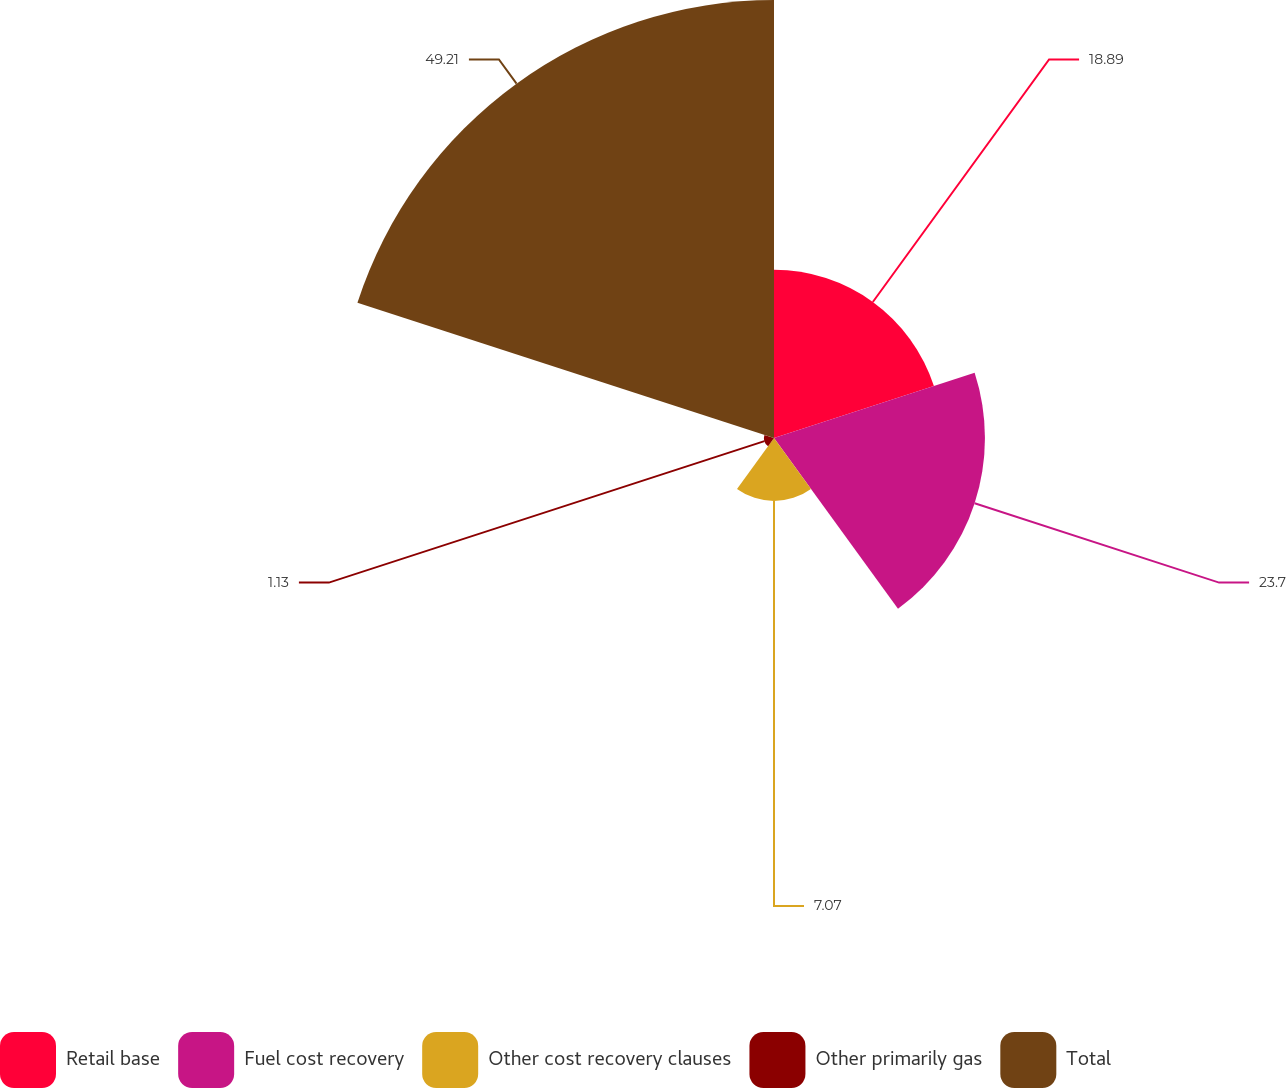Convert chart. <chart><loc_0><loc_0><loc_500><loc_500><pie_chart><fcel>Retail base<fcel>Fuel cost recovery<fcel>Other cost recovery clauses<fcel>Other primarily gas<fcel>Total<nl><fcel>18.89%<fcel>23.7%<fcel>7.07%<fcel>1.13%<fcel>49.21%<nl></chart> 